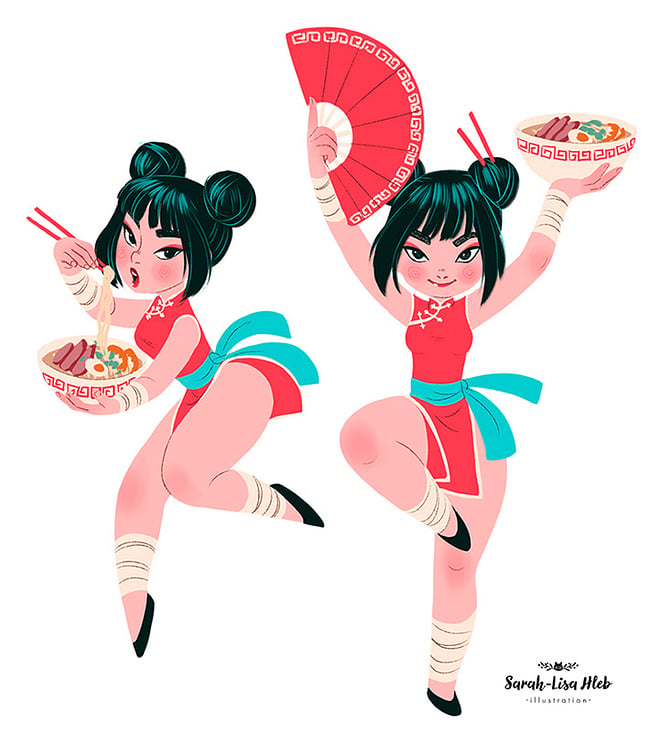What might the choice of colors in the image suggest about the mood or theme the illustrator intended to convey? The vivid reds and bright aqua tones suggest a lively, energetic mood, echoing themes of joy and celebration. Red often symbolizes good fortune and happiness in many Asian cultures, while the aqua adds a youthful, fresh vibe. These color choices likely aim to evoke a sense of festivity and vitality, enhancing the cultural celebration depicted through the characters' activities and attire. 